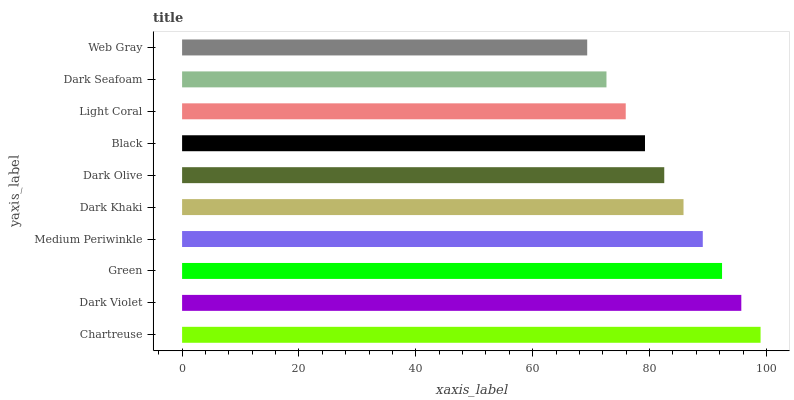Is Web Gray the minimum?
Answer yes or no. Yes. Is Chartreuse the maximum?
Answer yes or no. Yes. Is Dark Violet the minimum?
Answer yes or no. No. Is Dark Violet the maximum?
Answer yes or no. No. Is Chartreuse greater than Dark Violet?
Answer yes or no. Yes. Is Dark Violet less than Chartreuse?
Answer yes or no. Yes. Is Dark Violet greater than Chartreuse?
Answer yes or no. No. Is Chartreuse less than Dark Violet?
Answer yes or no. No. Is Dark Khaki the high median?
Answer yes or no. Yes. Is Dark Olive the low median?
Answer yes or no. Yes. Is Black the high median?
Answer yes or no. No. Is Dark Seafoam the low median?
Answer yes or no. No. 